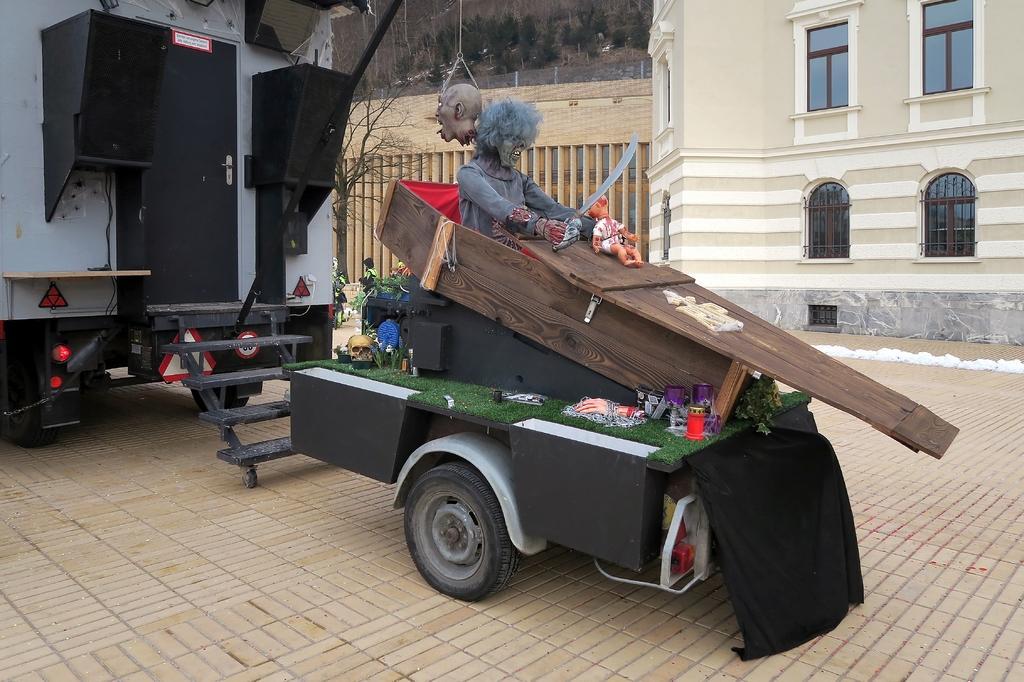Please provide a concise description of this image. In this image in the center there is one vehicle, and there is one coffin in that coffin there are some toys and also there are two objects. In the background there is another vehicle and some buildings and trees. 